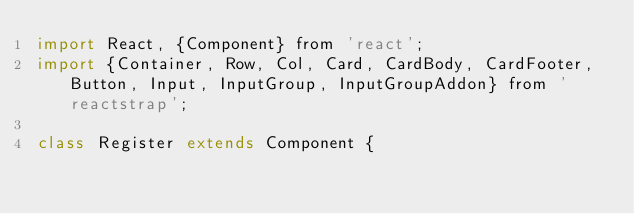<code> <loc_0><loc_0><loc_500><loc_500><_JavaScript_>import React, {Component} from 'react';
import {Container, Row, Col, Card, CardBody, CardFooter, Button, Input, InputGroup, InputGroupAddon} from 'reactstrap';

class Register extends Component {</code> 